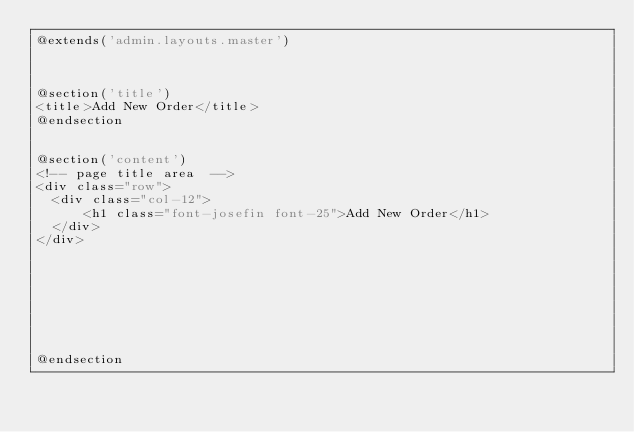Convert code to text. <code><loc_0><loc_0><loc_500><loc_500><_PHP_>@extends('admin.layouts.master')



@section('title')
<title>Add New Order</title>
@endsection


@section('content')
<!-- page title area  -->
<div class="row">
  <div class="col-12">
      <h1 class="font-josefin font-25">Add New Order</h1>
  </div>
</div>








@endsection</code> 